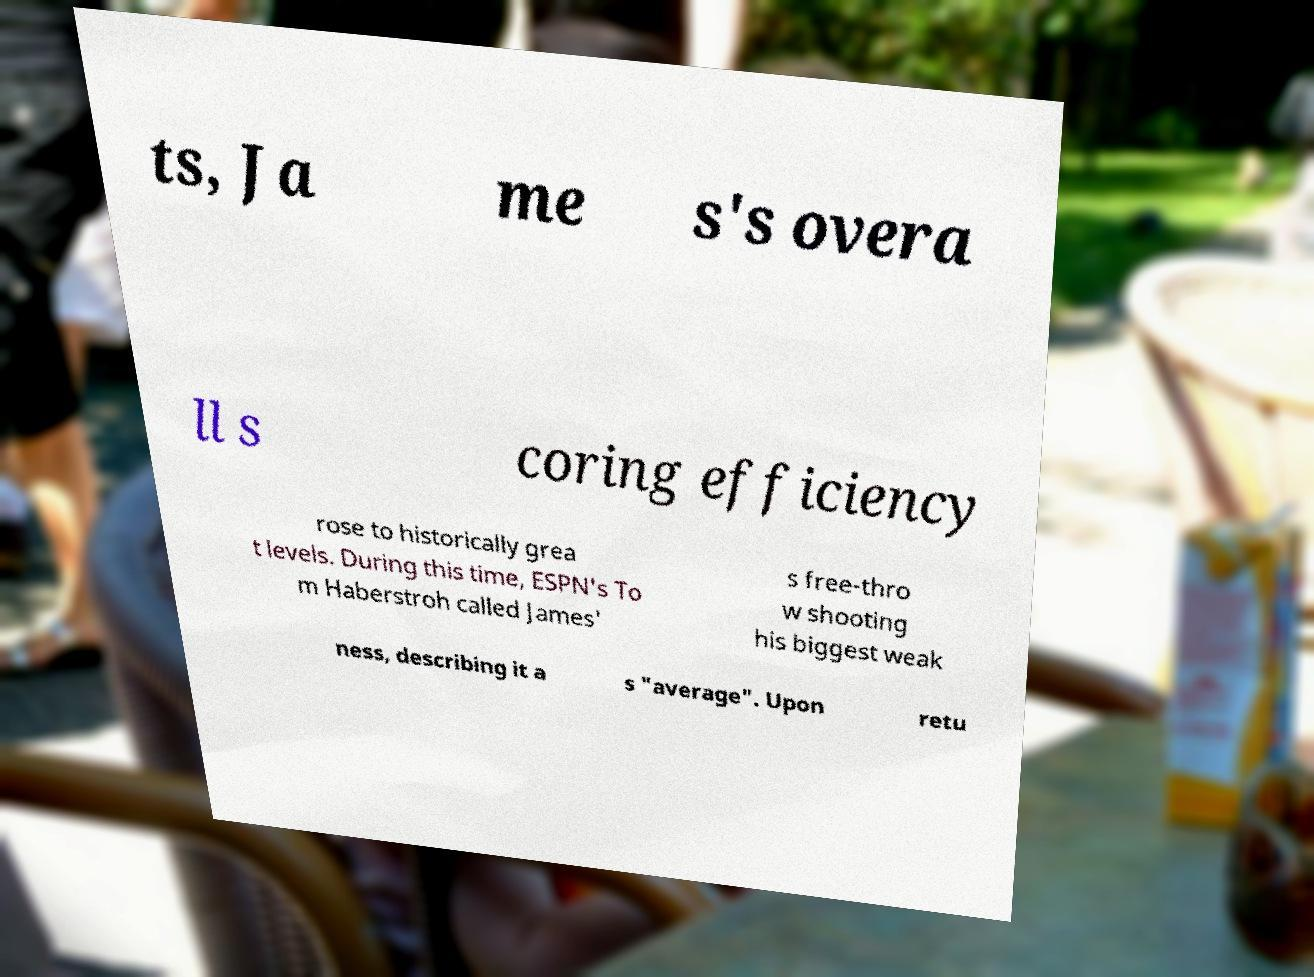What messages or text are displayed in this image? I need them in a readable, typed format. ts, Ja me s's overa ll s coring efficiency rose to historically grea t levels. During this time, ESPN's To m Haberstroh called James' s free-thro w shooting his biggest weak ness, describing it a s "average". Upon retu 